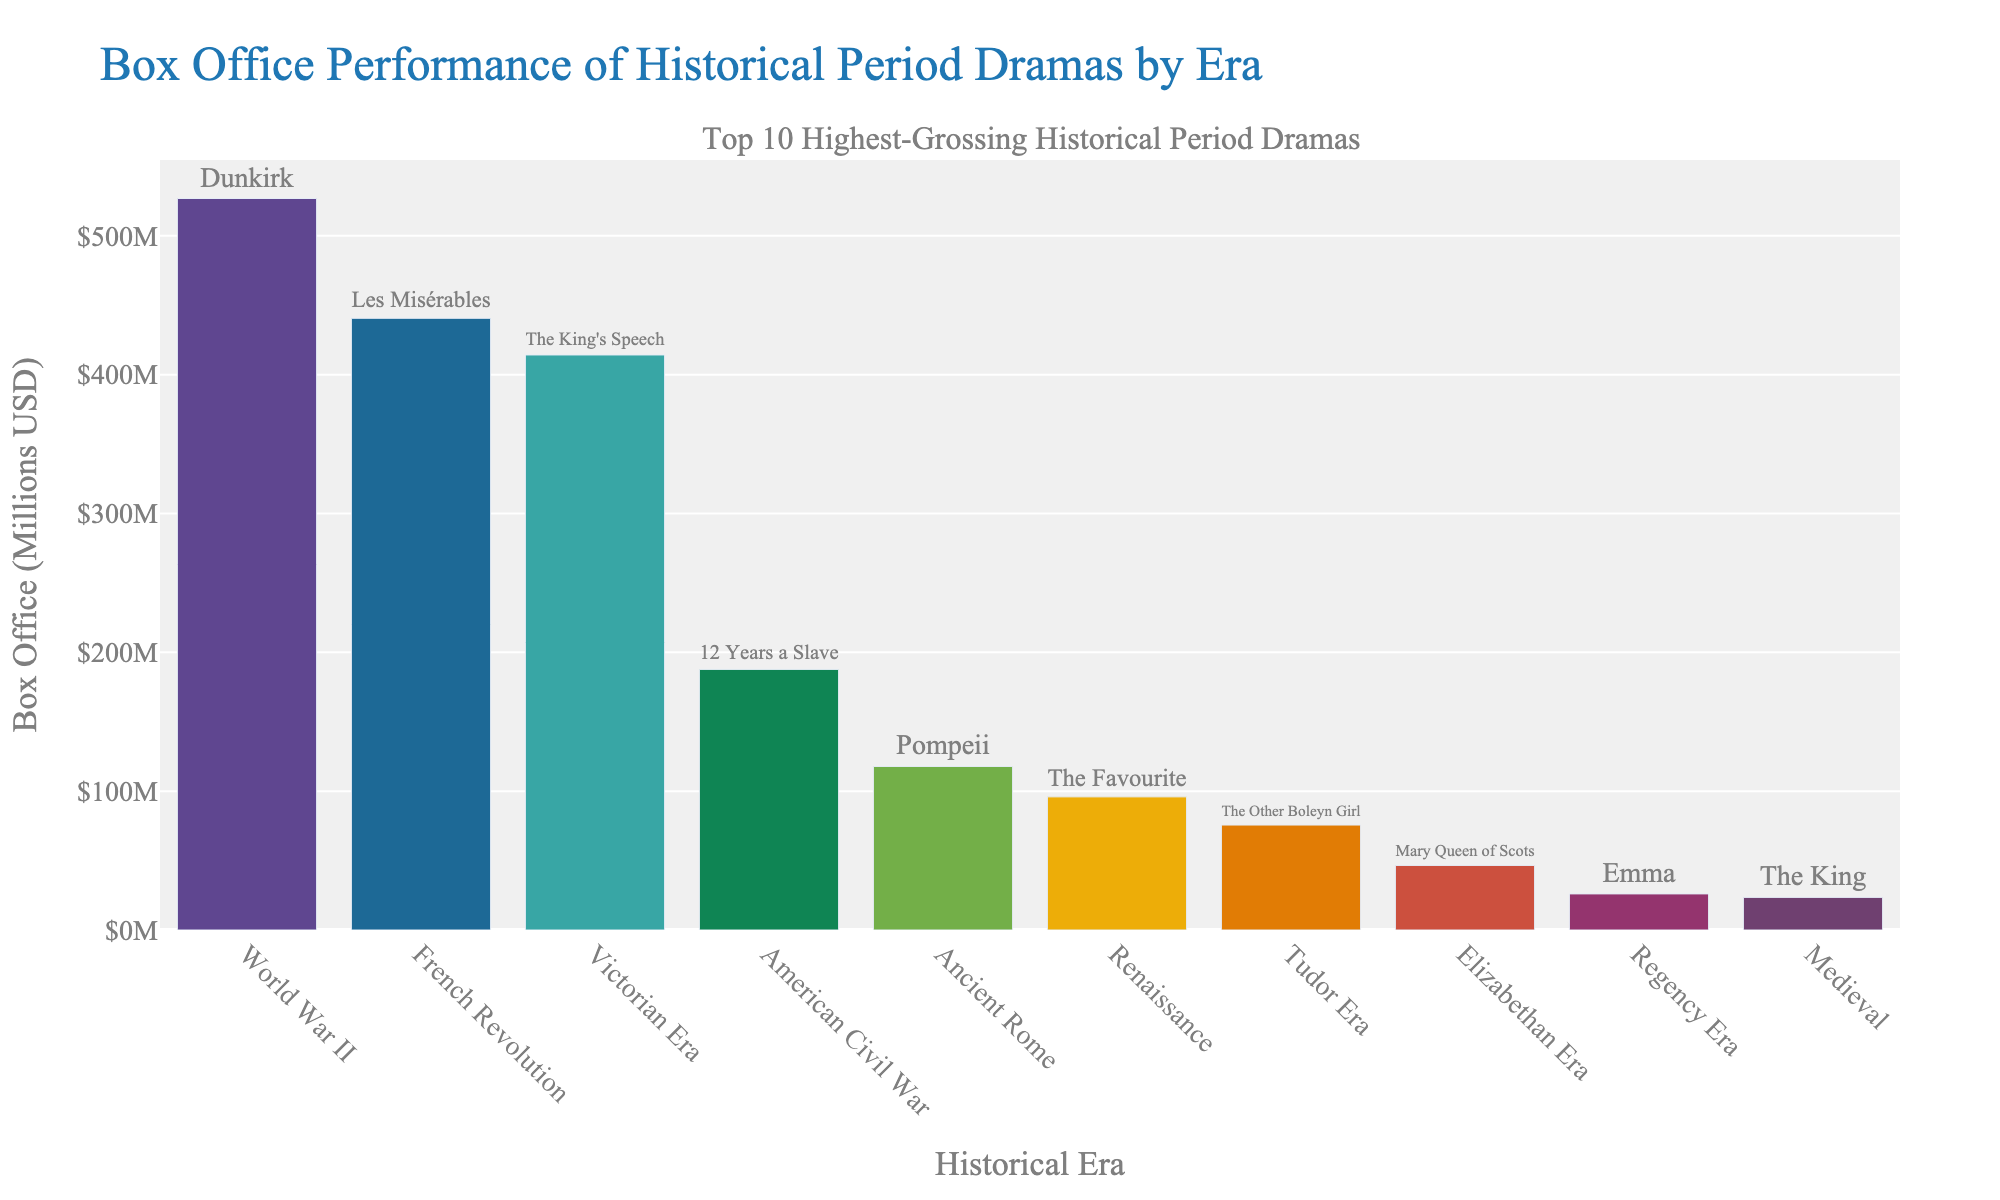What era is depicted in the highest-grossing historical period drama? The era depicted in the highest-grossing film is determined by identifying the bar with the greatest height on the chart. The tallest bar represents "Dunkirk," a World War II movie with the highest box office of $526.9 million.
Answer: World War II Which movie in the Victorian Era has the highest box office, and what is its amount? Find the bar labeled "Victorian Era" and check the corresponding movie title and box office amount. "The King's Speech" in the Victorian Era has a box office of $414.2 million.
Answer: The King's Speech, $414.2 million How does the box office performance of "Dunkirk" compare to "Les Misérables"? Identify the heights of the bars representing "Dunkirk" and "Les Misérables." "Dunkirk" has a box office of $526.9 million while "Les Misérables" has $440.6 million. Subtract $440.6 million from $526.9 million to get the difference.
Answer: $86.3 million higher Which two eras have movies with a box office close to $400 million? Check the bar heights around $400 million. "The King's Speech" in the Victorian Era ($414.2 million) and "Les Misérables" in the French Revolution Era ($440.6 million) are close to $400 million.
Answer: Victorian Era, French Revolution Era What is the total box office for all the movies depicted in the Renaissance and Regency Eras combined? Sum the box office earnings of "The Favourite" (Renaissance Era, $95.9 million) and "Emma" (Regency Era, $26.0 million). $95.9 million + $26.0 million = $121.9 million.
Answer: $121.9 million Compare the total box office earnings of movies from the Tudor Era and Ancient Rome. Which era has higher earnings and by how much? Addition of box office values: "The Other Boleyn Girl" (Tudor Era, $75.6 million) and "Pompeii" (Ancient Rome, $117.8 million). Subtract the Tudor Era's total from Ancient Rome's total: $117.8 million - $75.6 million.
Answer: Ancient Rome, $42.2 million higher Among the eras with a box office less than $50 million, which era’s movie title is associated, and what are the total earnings from this subset? Find bars below $50 million and their corresponding eras: "Mary Queen of Scots" (Elizabethan Era, $46.5 million) and "The King" (Medieval, $23.5 million). Add their earnings: $46.5 million + $23.5 million = $70.0 million.
Answer: Elizabethan Era & Medieval, $70 million Which bar has a darker color and represents a movie set in the French Revolution Era? Look for the bar representing "Les Misérables." Compare its color visually with other bars to identify the darker one. Verify it's the French Revolution Era's "Les Misérables."
Answer: Les Misérables What is the average box office revenue for the top 5 highest-grossing historical period dramas? Identify the top 5 highest-grossing bars: "Dunkirk" ($526.9 million), "Les Misérables" ($440.6 million), "The King's Speech" ($414.2 million), "12 Years a Slave" ($187.7 million), "Pompeii" ($117.8 million). Calculate the average: (526.9 + 440.6 + 414.2 + 187.7 + 117.8) / 5 = $337.44 million.
Answer: $337.44 million 